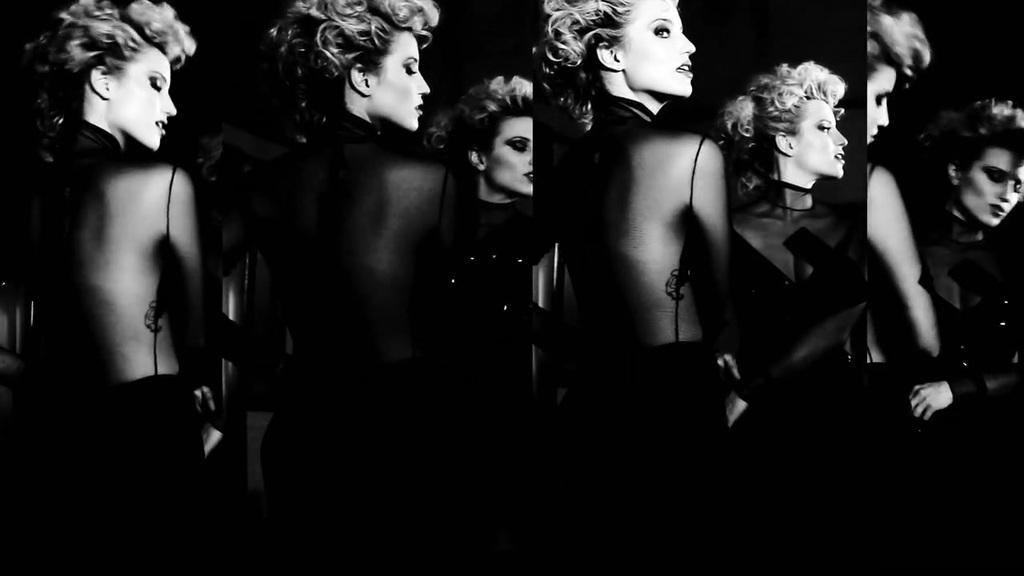Could you give a brief overview of what you see in this image? In this picture, it seems like a collage of a woman. 